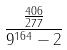<formula> <loc_0><loc_0><loc_500><loc_500>\frac { \frac { 4 0 6 } { 2 7 7 } } { 9 ^ { 1 6 4 } - 2 }</formula> 